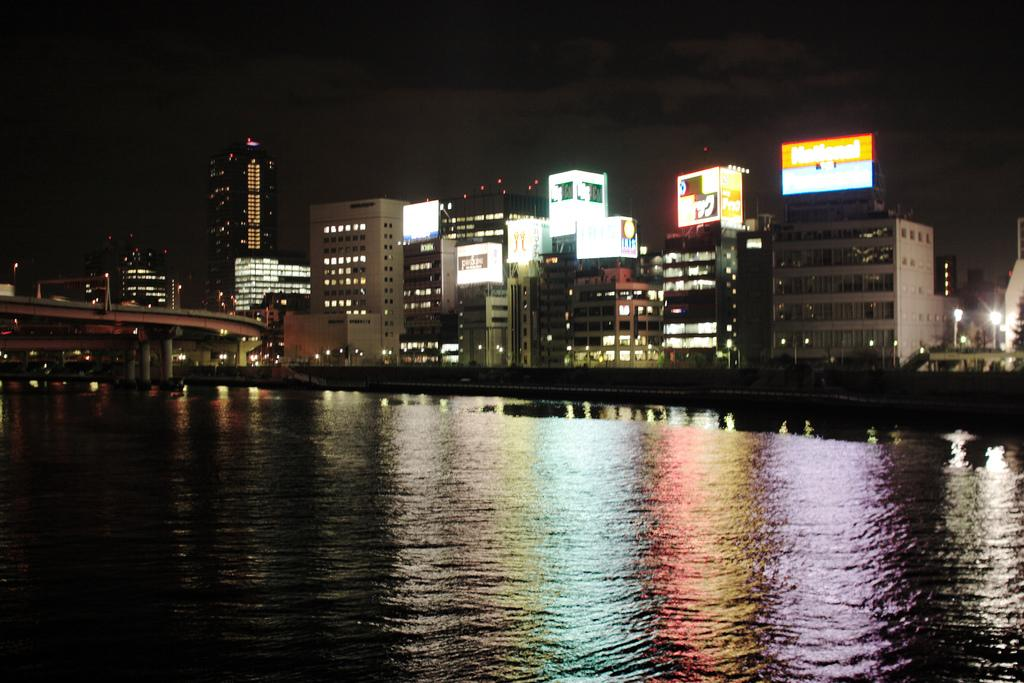What is visible in the image? Water is visible in the image. How long is the tail of the monkey in the image? There is no monkey present in the image, so it is not possible to determine the length of its tail. 